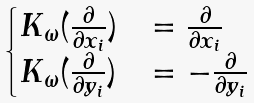Convert formula to latex. <formula><loc_0><loc_0><loc_500><loc_500>\begin{cases} K _ { \omega } ( \frac { \partial } { \partial x _ { i } } ) & = \frac { \partial } { \partial x _ { i } } \\ K _ { \omega } ( \frac { \partial } { \partial y _ { i } } ) & = - \frac { \partial } { \partial y _ { i } } \\ \end{cases}</formula> 